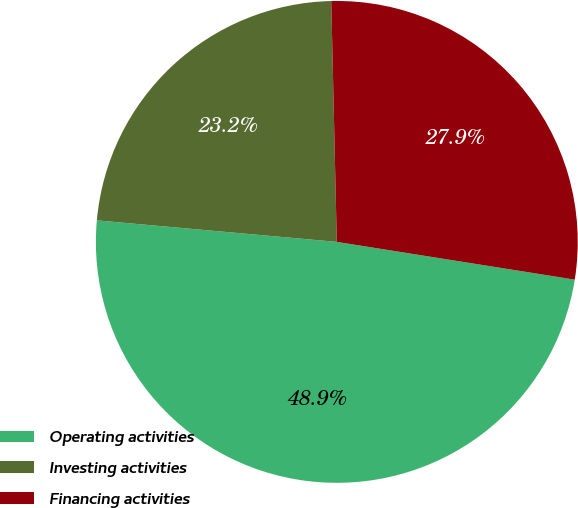<chart> <loc_0><loc_0><loc_500><loc_500><pie_chart><fcel>Operating activities<fcel>Investing activities<fcel>Financing activities<nl><fcel>48.92%<fcel>23.21%<fcel>27.87%<nl></chart> 